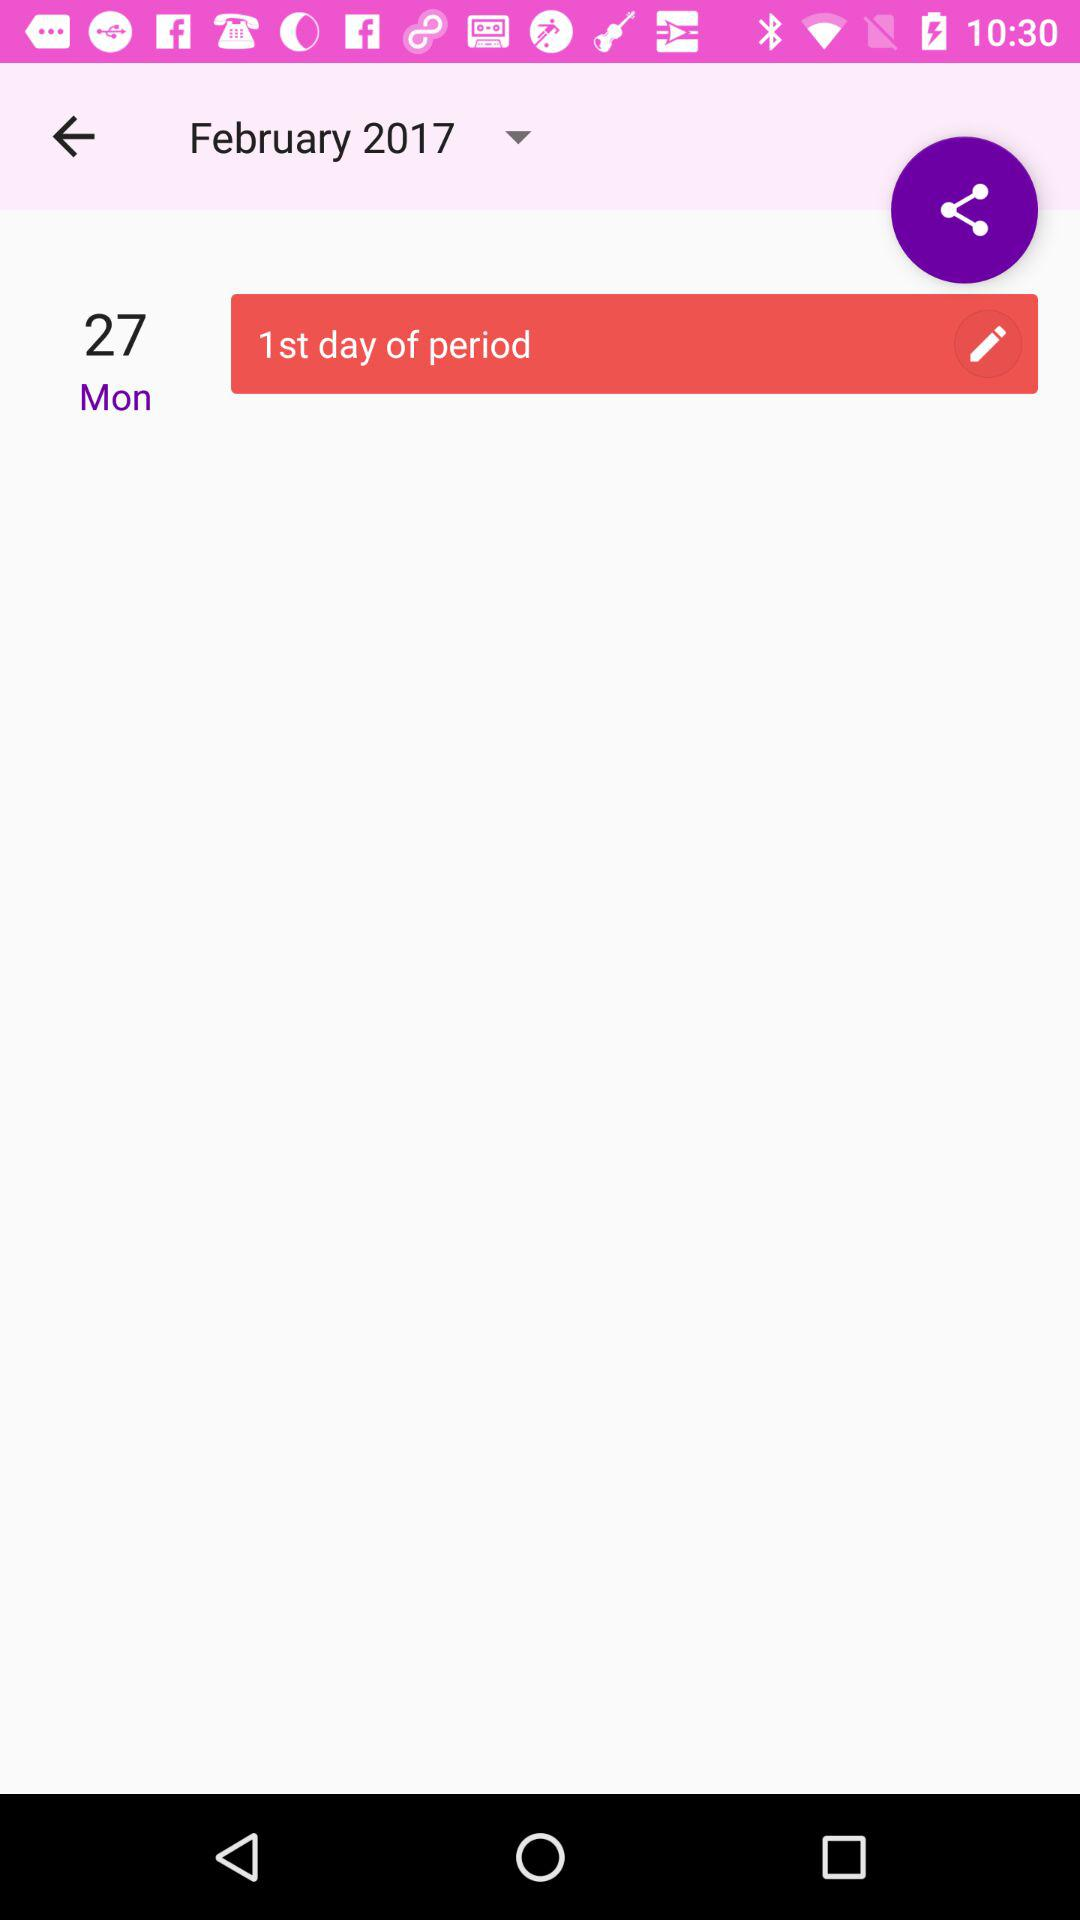What is the date of the period? The date of the period is February 27, 2017. 